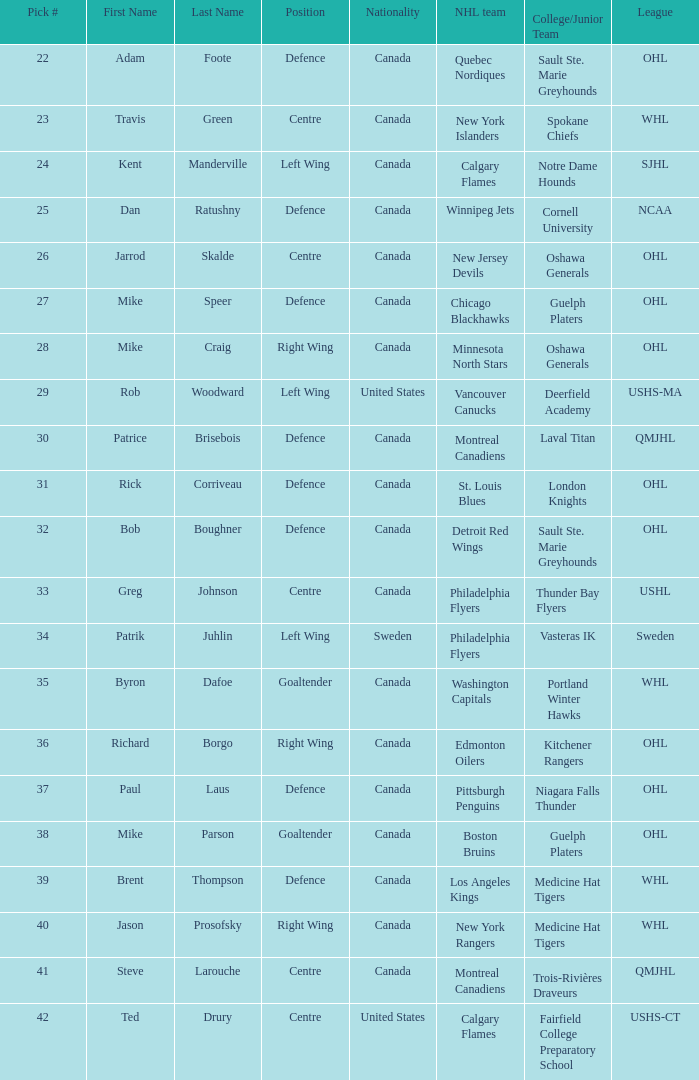Write the full table. {'header': ['Pick #', 'First Name', 'Last Name', 'Position', 'Nationality', 'NHL team', 'College/Junior Team', 'League'], 'rows': [['22', 'Adam', 'Foote', 'Defence', 'Canada', 'Quebec Nordiques', 'Sault Ste. Marie Greyhounds', 'OHL'], ['23', 'Travis', 'Green', 'Centre', 'Canada', 'New York Islanders', 'Spokane Chiefs', 'WHL'], ['24', 'Kent', 'Manderville', 'Left Wing', 'Canada', 'Calgary Flames', 'Notre Dame Hounds', 'SJHL'], ['25', 'Dan', 'Ratushny', 'Defence', 'Canada', 'Winnipeg Jets', 'Cornell University', 'NCAA'], ['26', 'Jarrod', 'Skalde', 'Centre', 'Canada', 'New Jersey Devils', 'Oshawa Generals', 'OHL'], ['27', 'Mike', 'Speer', 'Defence', 'Canada', 'Chicago Blackhawks', 'Guelph Platers', 'OHL'], ['28', 'Mike', 'Craig', 'Right Wing', 'Canada', 'Minnesota North Stars', 'Oshawa Generals', 'OHL'], ['29', 'Rob', 'Woodward', 'Left Wing', 'United States', 'Vancouver Canucks', 'Deerfield Academy', 'USHS-MA'], ['30', 'Patrice', 'Brisebois', 'Defence', 'Canada', 'Montreal Canadiens', 'Laval Titan', 'QMJHL'], ['31', 'Rick', 'Corriveau', 'Defence', 'Canada', 'St. Louis Blues', 'London Knights', 'OHL'], ['32', 'Bob', 'Boughner', 'Defence', 'Canada', 'Detroit Red Wings', 'Sault Ste. Marie Greyhounds', 'OHL'], ['33', 'Greg', 'Johnson', 'Centre', 'Canada', 'Philadelphia Flyers', 'Thunder Bay Flyers', 'USHL'], ['34', 'Patrik', 'Juhlin', 'Left Wing', 'Sweden', 'Philadelphia Flyers', 'Vasteras IK', 'Sweden'], ['35', 'Byron', 'Dafoe', 'Goaltender', 'Canada', 'Washington Capitals', 'Portland Winter Hawks', 'WHL'], ['36', 'Richard', 'Borgo', 'Right Wing', 'Canada', 'Edmonton Oilers', 'Kitchener Rangers', 'OHL'], ['37', 'Paul', 'Laus', 'Defence', 'Canada', 'Pittsburgh Penguins', 'Niagara Falls Thunder', 'OHL'], ['38', 'Mike', 'Parson', 'Goaltender', 'Canada', 'Boston Bruins', 'Guelph Platers', 'OHL'], ['39', 'Brent', 'Thompson', 'Defence', 'Canada', 'Los Angeles Kings', 'Medicine Hat Tigers', 'WHL'], ['40', 'Jason', 'Prosofsky', 'Right Wing', 'Canada', 'New York Rangers', 'Medicine Hat Tigers', 'WHL'], ['41', 'Steve', 'Larouche', 'Centre', 'Canada', 'Montreal Canadiens', 'Trois-Rivières Draveurs', 'QMJHL'], ['42', 'Ted', 'Drury', 'Centre', 'United States', 'Calgary Flames', 'Fairfield College Preparatory School', 'USHS-CT']]} What is the nationality of the draft pick player who plays centre position and is going to Calgary Flames? United States. 